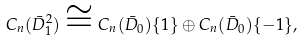Convert formula to latex. <formula><loc_0><loc_0><loc_500><loc_500>C _ { n } ( \bar { D } _ { 1 } ^ { 2 } ) \cong C _ { n } ( \bar { D } _ { 0 } ) \{ 1 \} \oplus C _ { n } ( \bar { D } _ { 0 } ) \{ - 1 \} ,</formula> 